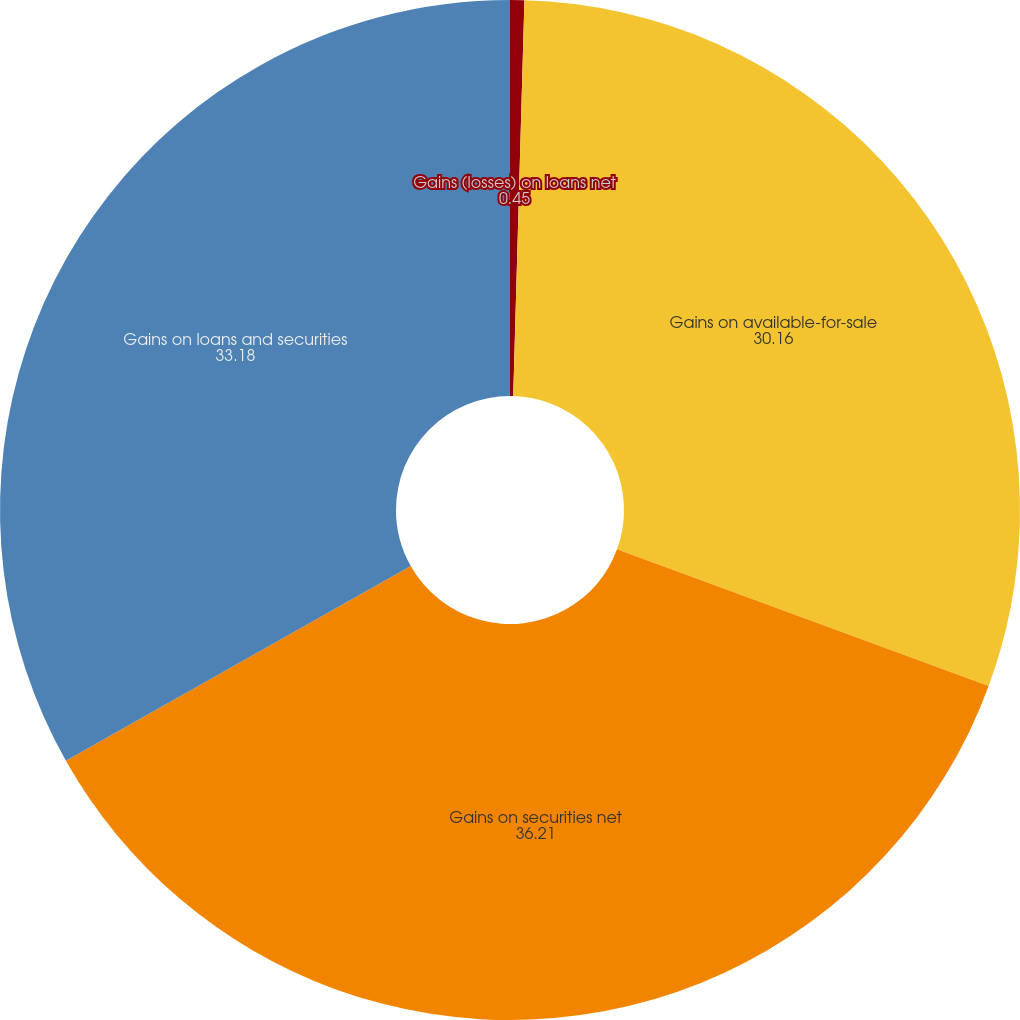Convert chart to OTSL. <chart><loc_0><loc_0><loc_500><loc_500><pie_chart><fcel>Gains (losses) on loans net<fcel>Gains on available-for-sale<fcel>Gains on securities net<fcel>Gains on loans and securities<nl><fcel>0.45%<fcel>30.16%<fcel>36.21%<fcel>33.18%<nl></chart> 